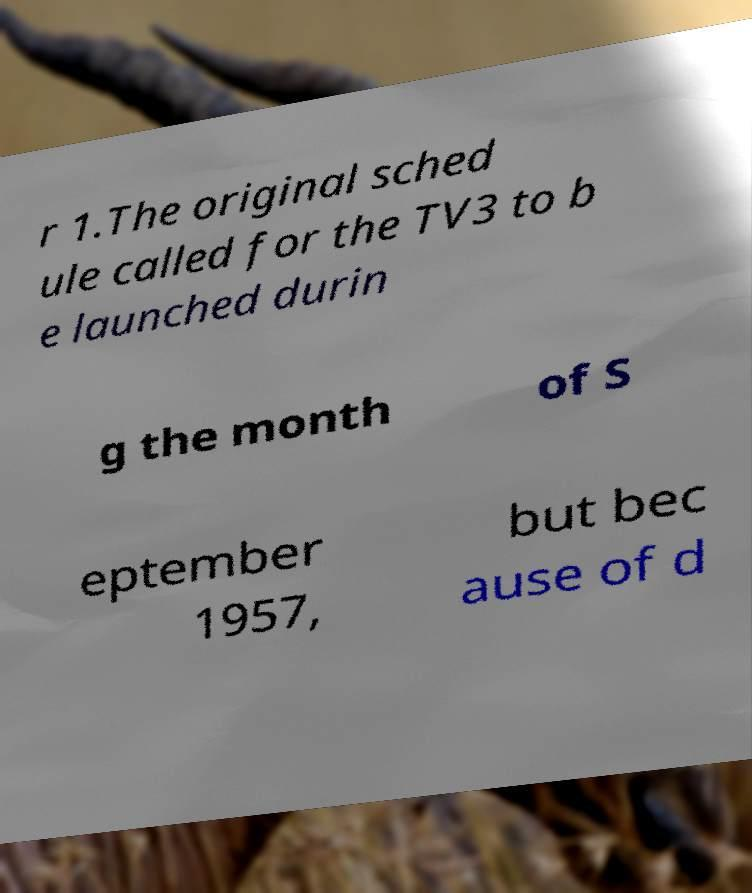Could you assist in decoding the text presented in this image and type it out clearly? r 1.The original sched ule called for the TV3 to b e launched durin g the month of S eptember 1957, but bec ause of d 